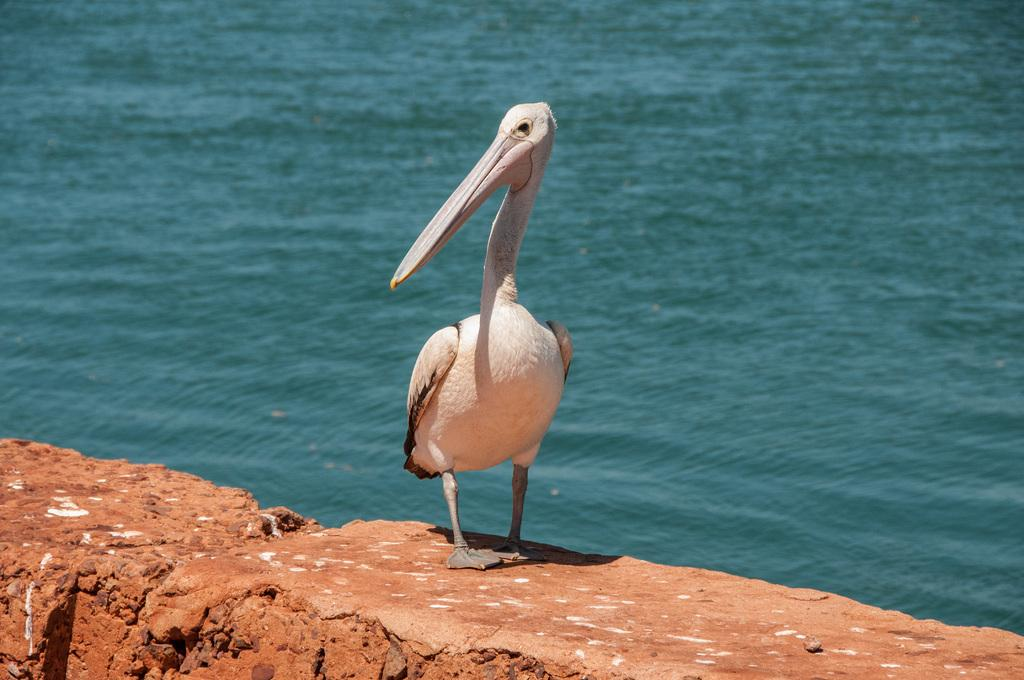What is the main subject in the center of the image? There is a bird in the center of the image. Where is the bird located? The bird is on a wall. What can be seen in the background of the image? There is water visible in the background of the image. What type of cracker is the bird holding in its beak in the image? There is no cracker present in the image; the bird is not holding anything in its beak. 